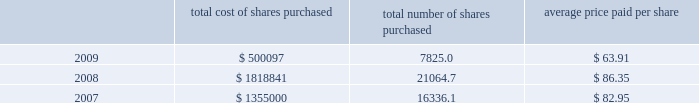Part ii , item 7 until maturity , effectively making this a us dollar denominated debt on which schlumberger will pay interest in us dollars at a rate of 4.74% ( 4.74 % ) .
The proceeds from these notes were used to repay commercial paper borrowings .
0160 on april 20 , 2006 , the schlumberger board of directors approved a share repurchase program of up to 40 million shares of common stock to be acquired in the open market before april 2010 , subject to market conditions .
This program was completed during the second quarter of 2008 .
On april 17 , 2008 , the schlumberger board of directors approved an $ 8 billion share repurchase program for shares of schlumberger common stock , to be acquired in the open market before december 31 , 2011 , of which $ 1.43 billion had been repurchased as of december 31 , 2009 .
The table summarizes the activity under these share repurchase programs during 2009 , 2008 and ( stated in thousands except per share amounts and prices ) total cost of shares purchased total number of shares purchased average price paid per share .
0160 cash flow provided by operations was $ 5.3 billion in 2009 , $ 6.9 billion in 2008 and $ 6.3 billion in 2007 .
The decline in cash flow from operations in 2009 as compared to 2008 was primarily driven by the decrease in net income experienced in 2009 and the significant pension plan contributions made during 2009 , offset by an improvement in working capital requirements .
The improvement in 2008 as compared to 2007 was driven by the net income increase experienced in 2008 offset by required investments in working capital .
The reduction in cash flows experienced by some of schlumberger 2019s customers as a result of global economic conditions could have significant adverse effects on their financial condition .
This could result in , among other things , delay in , or nonpayment of , amounts that are owed to schlumberger , which could have a material adverse effect on schlumberger 2019s results of operations and cash flows .
At times in recent quarters , schlumberger has experienced delays in payments from certain of its customers .
Schlumberger operates in approximately 80 countries .
At december 31 , 2009 , only three of those countries individually accounted for greater than 5% ( 5 % ) of schlumberger 2019s accounts receivable balance of which only one represented greater than 0160 during 2008 and 2007 , schlumberger announced that its board of directors had approved increases in the quarterly dividend of 20% ( 20 % ) and 40% ( 40 % ) , respectively .
Total dividends paid during 2009 , 2008 and 2007 were $ 1.0 billion , $ 964 million and $ 771 million , respectively .
0160 capital expenditures were $ 2.4 billion in 2009 , $ 3.7 billion in 2008 and $ 2.9 billion in 2007 .
Capital expenditures in 2008 and 2007 reflected the record activity levels experienced in those years .
The decrease in capital expenditures in 2009 as compared to 2008 is primarily due to the significant activity decline during 2009 .
Oilfield services capital expenditures are expected to approach $ 2.4 billion for the full year 2010 as compared to $ 1.9 billion in 2009 and $ 3.0 billion in 2008 .
Westerngeco capital expenditures are expected to approach $ 0.3 billion for the full year 2010 as compared to $ 0.5 billion in 2009 and $ 0.7 billion in 2008. .
By how much did the average price per share decrease from 2007 to 2009? 
Computations: ((63.91 - 82.95) / 82.95)
Answer: -0.22954. Part ii , item 7 until maturity , effectively making this a us dollar denominated debt on which schlumberger will pay interest in us dollars at a rate of 4.74% ( 4.74 % ) .
The proceeds from these notes were used to repay commercial paper borrowings .
0160 on april 20 , 2006 , the schlumberger board of directors approved a share repurchase program of up to 40 million shares of common stock to be acquired in the open market before april 2010 , subject to market conditions .
This program was completed during the second quarter of 2008 .
On april 17 , 2008 , the schlumberger board of directors approved an $ 8 billion share repurchase program for shares of schlumberger common stock , to be acquired in the open market before december 31 , 2011 , of which $ 1.43 billion had been repurchased as of december 31 , 2009 .
The table summarizes the activity under these share repurchase programs during 2009 , 2008 and ( stated in thousands except per share amounts and prices ) total cost of shares purchased total number of shares purchased average price paid per share .
0160 cash flow provided by operations was $ 5.3 billion in 2009 , $ 6.9 billion in 2008 and $ 6.3 billion in 2007 .
The decline in cash flow from operations in 2009 as compared to 2008 was primarily driven by the decrease in net income experienced in 2009 and the significant pension plan contributions made during 2009 , offset by an improvement in working capital requirements .
The improvement in 2008 as compared to 2007 was driven by the net income increase experienced in 2008 offset by required investments in working capital .
The reduction in cash flows experienced by some of schlumberger 2019s customers as a result of global economic conditions could have significant adverse effects on their financial condition .
This could result in , among other things , delay in , or nonpayment of , amounts that are owed to schlumberger , which could have a material adverse effect on schlumberger 2019s results of operations and cash flows .
At times in recent quarters , schlumberger has experienced delays in payments from certain of its customers .
Schlumberger operates in approximately 80 countries .
At december 31 , 2009 , only three of those countries individually accounted for greater than 5% ( 5 % ) of schlumberger 2019s accounts receivable balance of which only one represented greater than 0160 during 2008 and 2007 , schlumberger announced that its board of directors had approved increases in the quarterly dividend of 20% ( 20 % ) and 40% ( 40 % ) , respectively .
Total dividends paid during 2009 , 2008 and 2007 were $ 1.0 billion , $ 964 million and $ 771 million , respectively .
0160 capital expenditures were $ 2.4 billion in 2009 , $ 3.7 billion in 2008 and $ 2.9 billion in 2007 .
Capital expenditures in 2008 and 2007 reflected the record activity levels experienced in those years .
The decrease in capital expenditures in 2009 as compared to 2008 is primarily due to the significant activity decline during 2009 .
Oilfield services capital expenditures are expected to approach $ 2.4 billion for the full year 2010 as compared to $ 1.9 billion in 2009 and $ 3.0 billion in 2008 .
Westerngeco capital expenditures are expected to approach $ 0.3 billion for the full year 2010 as compared to $ 0.5 billion in 2009 and $ 0.7 billion in 2008. .
By how much did the average price per share decrease from 2007 to 2009? 
Computations: ((63.91 - 82.95) / 82.95)
Answer: -0.22954. 